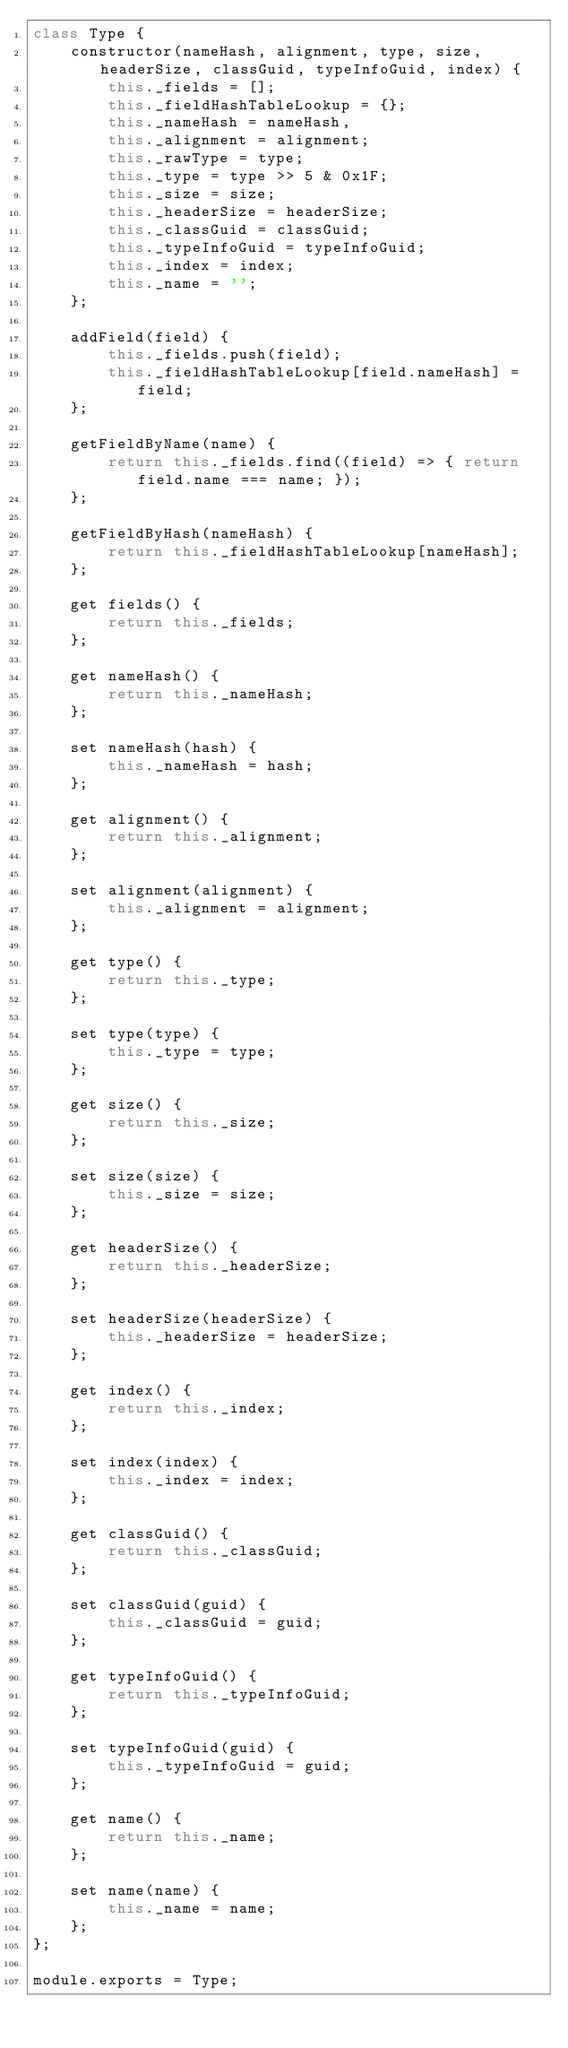<code> <loc_0><loc_0><loc_500><loc_500><_JavaScript_>class Type {
    constructor(nameHash, alignment, type, size, headerSize, classGuid, typeInfoGuid, index) {
        this._fields = [];
        this._fieldHashTableLookup = {};
        this._nameHash = nameHash,
        this._alignment = alignment;
        this._rawType = type;
        this._type = type >> 5 & 0x1F;
        this._size = size;
        this._headerSize = headerSize;
        this._classGuid = classGuid;
        this._typeInfoGuid = typeInfoGuid;
        this._index = index;
        this._name = '';
    };

    addField(field) {
        this._fields.push(field);
        this._fieldHashTableLookup[field.nameHash] = field;
    };

    getFieldByName(name) {
        return this._fields.find((field) => { return field.name === name; });
    };

    getFieldByHash(nameHash) {
        return this._fieldHashTableLookup[nameHash];
    };

    get fields() {
        return this._fields;
    };

    get nameHash() {
        return this._nameHash;
    };

    set nameHash(hash) {
        this._nameHash = hash;
    };

    get alignment() {
        return this._alignment;
    };

    set alignment(alignment) {
        this._alignment = alignment;
    };

    get type() {
        return this._type;
    };

    set type(type) {
        this._type = type;
    };

    get size() {
        return this._size;
    };

    set size(size) {
        this._size = size;
    };

    get headerSize() {
        return this._headerSize;
    };

    set headerSize(headerSize) {
        this._headerSize = headerSize;
    };

    get index() {
        return this._index;
    };

    set index(index) {
        this._index = index;
    };

    get classGuid() {
        return this._classGuid;
    };

    set classGuid(guid) {
        this._classGuid = guid;
    };

    get typeInfoGuid() {
        return this._typeInfoGuid;
    };

    set typeInfoGuid(guid) {
        this._typeInfoGuid = guid;
    };

    get name() {
        return this._name;
    };

    set name(name) {
        this._name = name;
    };
};

module.exports = Type;</code> 